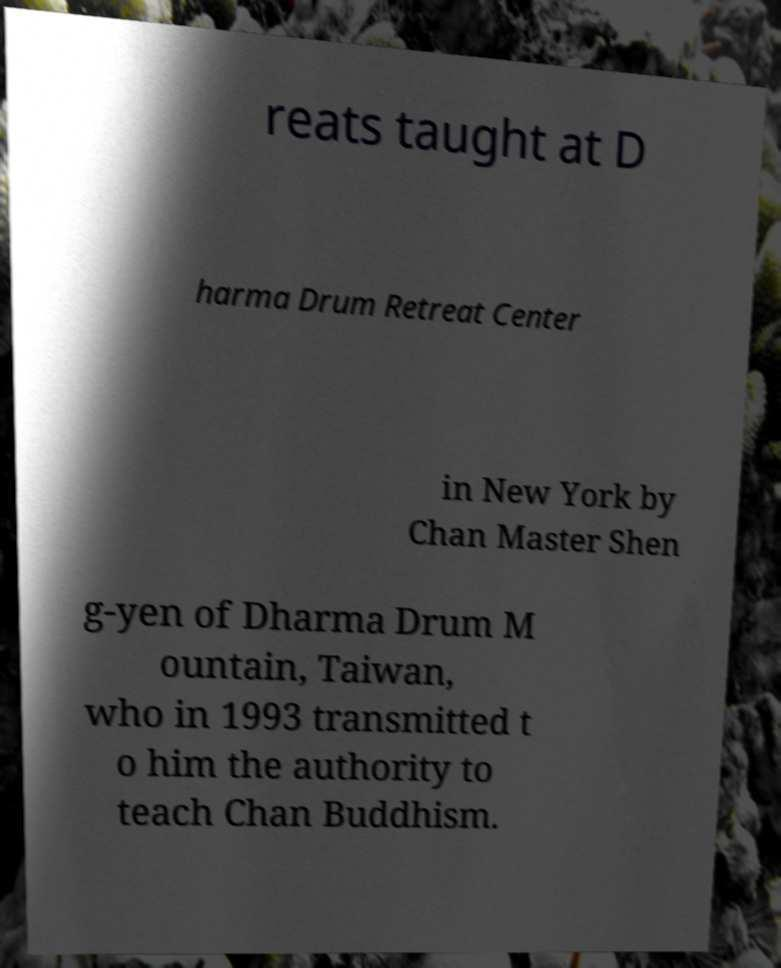There's text embedded in this image that I need extracted. Can you transcribe it verbatim? reats taught at D harma Drum Retreat Center in New York by Chan Master Shen g-yen of Dharma Drum M ountain, Taiwan, who in 1993 transmitted t o him the authority to teach Chan Buddhism. 